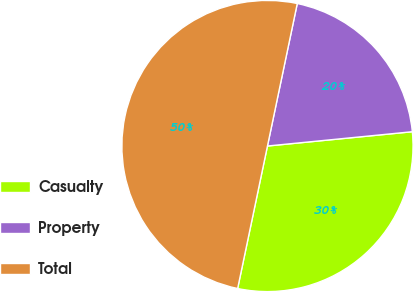Convert chart to OTSL. <chart><loc_0><loc_0><loc_500><loc_500><pie_chart><fcel>Casualty<fcel>Property<fcel>Total<nl><fcel>29.85%<fcel>20.15%<fcel>50.0%<nl></chart> 